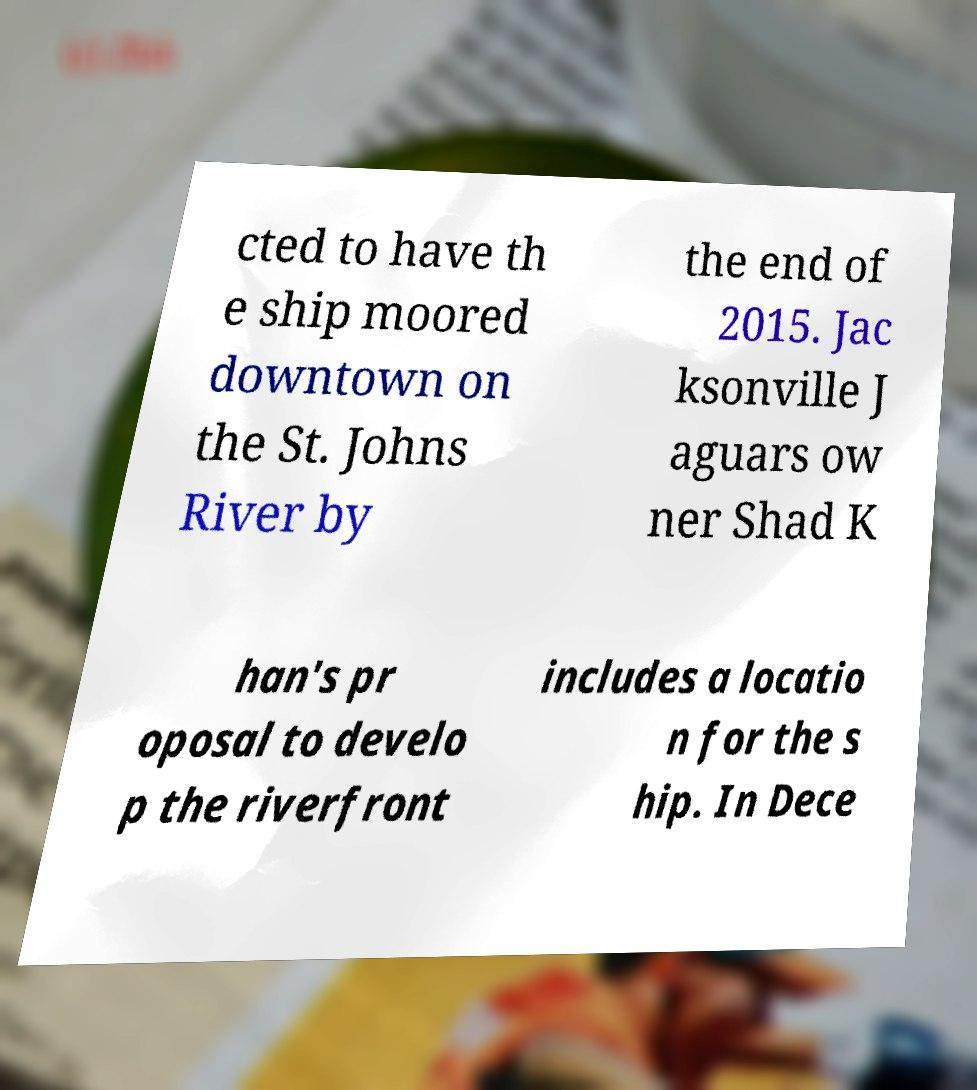What messages or text are displayed in this image? I need them in a readable, typed format. cted to have th e ship moored downtown on the St. Johns River by the end of 2015. Jac ksonville J aguars ow ner Shad K han's pr oposal to develo p the riverfront includes a locatio n for the s hip. In Dece 